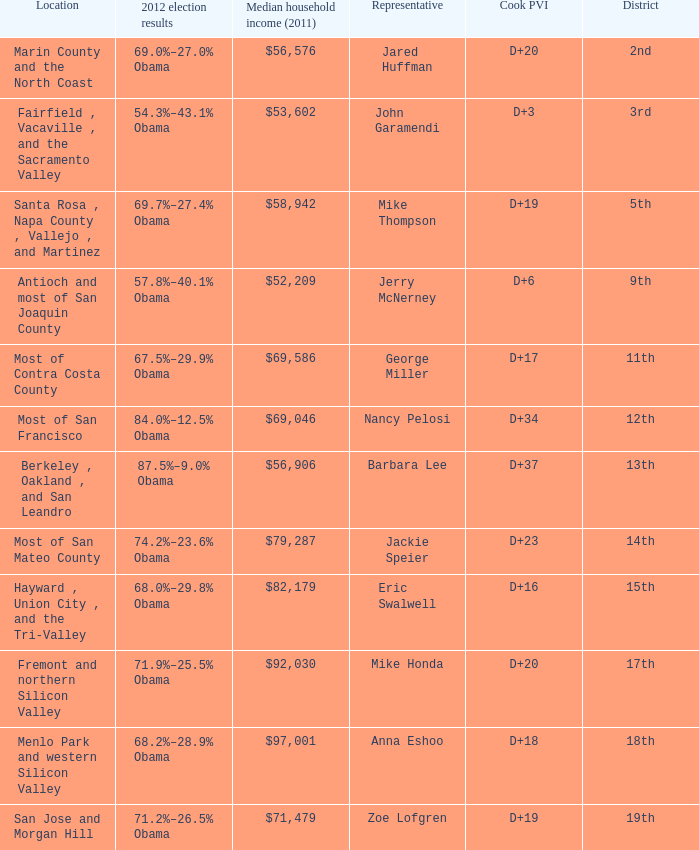How many election results in 2012 had a Cook PVI of D+16? 1.0. 